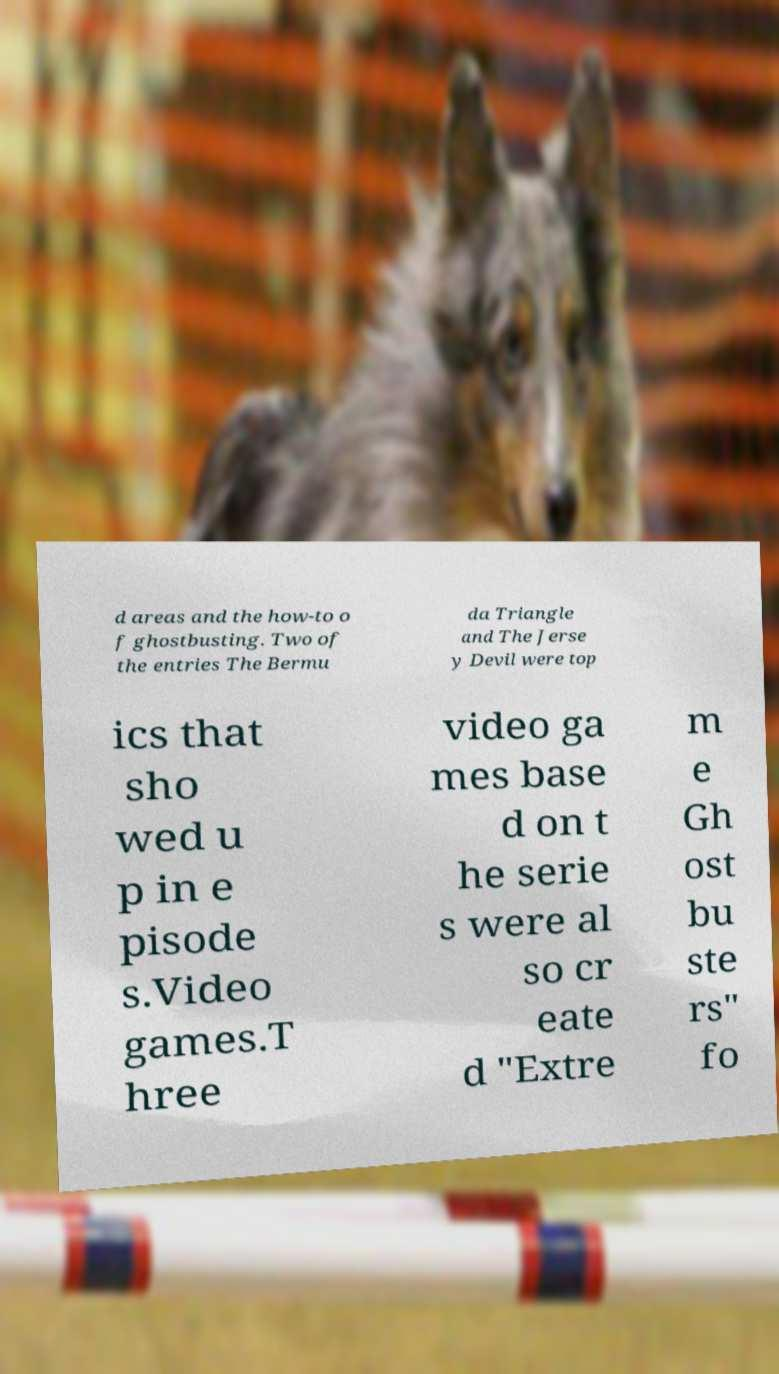Could you extract and type out the text from this image? d areas and the how-to o f ghostbusting. Two of the entries The Bermu da Triangle and The Jerse y Devil were top ics that sho wed u p in e pisode s.Video games.T hree video ga mes base d on t he serie s were al so cr eate d "Extre m e Gh ost bu ste rs" fo 